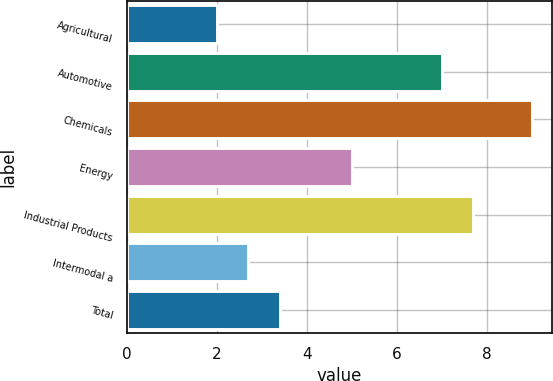Convert chart. <chart><loc_0><loc_0><loc_500><loc_500><bar_chart><fcel>Agricultural<fcel>Automotive<fcel>Chemicals<fcel>Energy<fcel>Industrial Products<fcel>Intermodal a<fcel>Total<nl><fcel>2<fcel>7<fcel>9<fcel>5<fcel>7.7<fcel>2.7<fcel>3.4<nl></chart> 